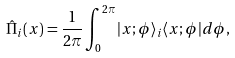Convert formula to latex. <formula><loc_0><loc_0><loc_500><loc_500>\hat { \Pi } _ { i } ( x ) = \frac { 1 } { 2 \pi } \int _ { 0 } ^ { 2 \pi } | x ; \phi \rangle _ { i } \langle x ; \phi | d \phi ,</formula> 